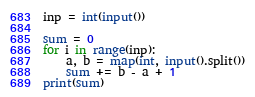Convert code to text. <code><loc_0><loc_0><loc_500><loc_500><_Python_>inp = int(input())

sum = 0
for i in range(inp):
	a, b = map(int, input().split())
	sum += b - a + 1
print(sum)</code> 